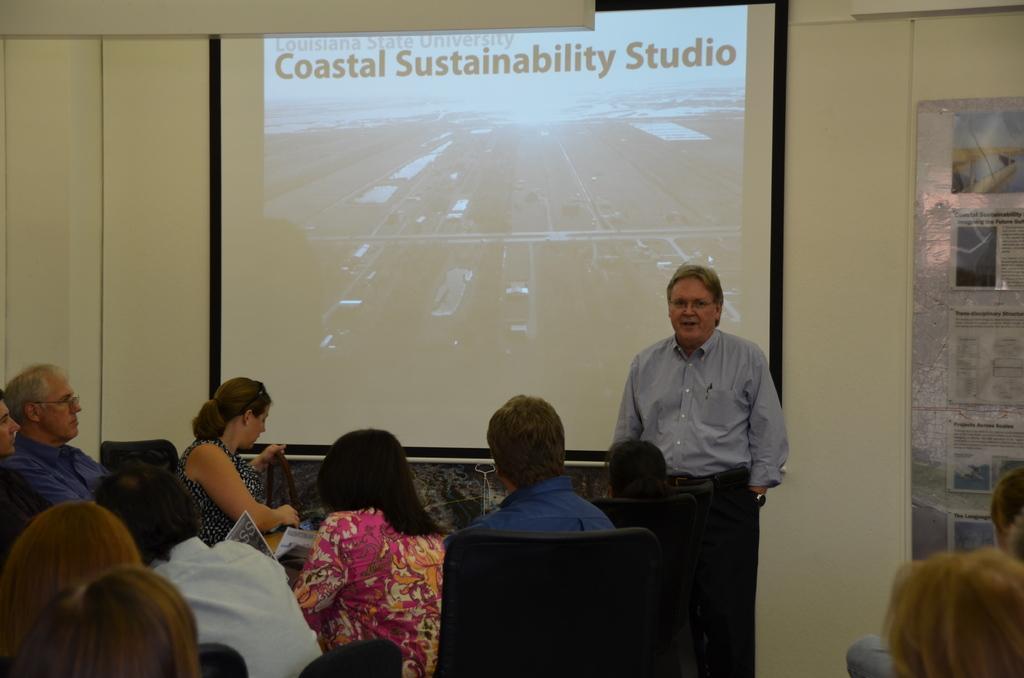How would you summarize this image in a sentence or two? This is the picture of a room. In this image there are group of people sitting and there is a person standing. At the back there is a screen and there is a text on the screen. On the right side of the image there are posters. At the back there is a wall. 